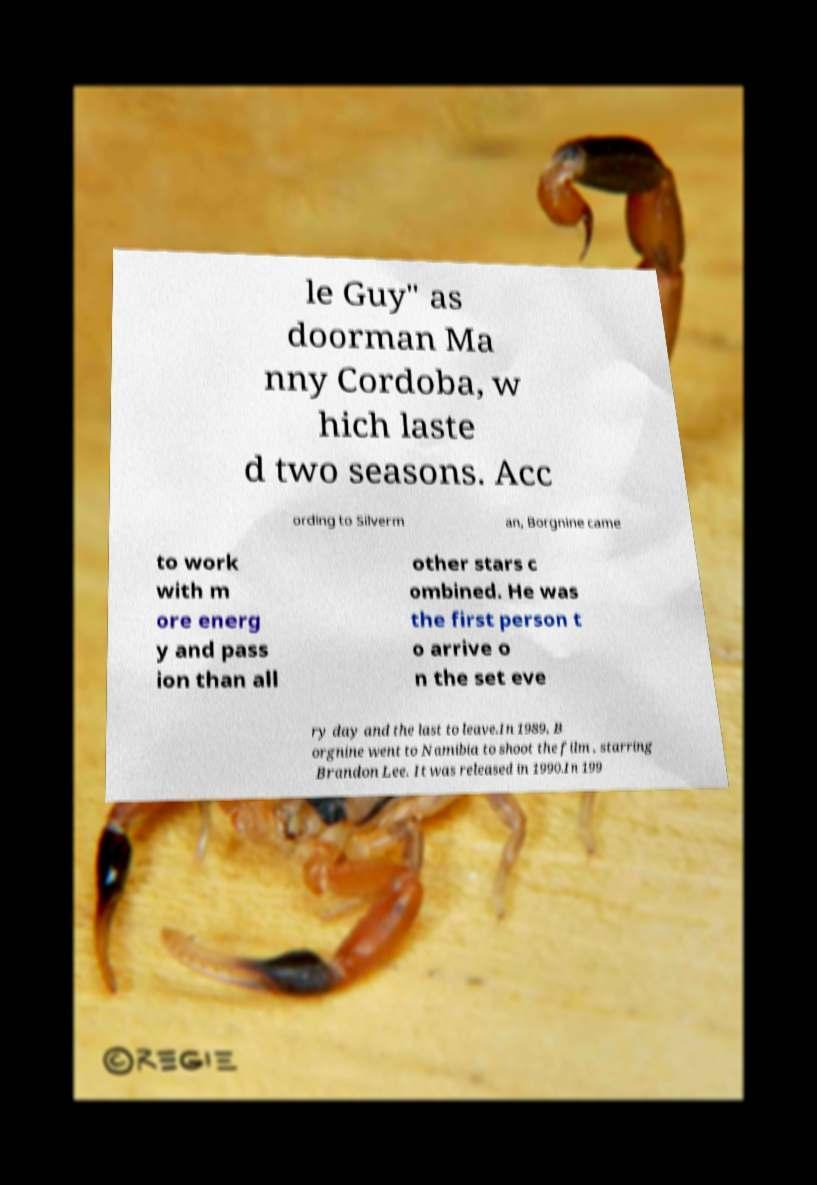Please read and relay the text visible in this image. What does it say? le Guy" as doorman Ma nny Cordoba, w hich laste d two seasons. Acc ording to Silverm an, Borgnine came to work with m ore energ y and pass ion than all other stars c ombined. He was the first person t o arrive o n the set eve ry day and the last to leave.In 1989, B orgnine went to Namibia to shoot the film , starring Brandon Lee. It was released in 1990.In 199 